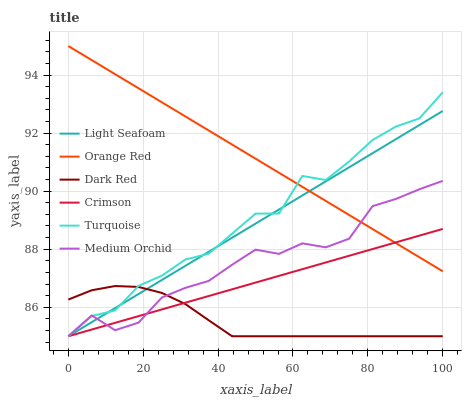Does Dark Red have the minimum area under the curve?
Answer yes or no. Yes. Does Orange Red have the maximum area under the curve?
Answer yes or no. Yes. Does Medium Orchid have the minimum area under the curve?
Answer yes or no. No. Does Medium Orchid have the maximum area under the curve?
Answer yes or no. No. Is Light Seafoam the smoothest?
Answer yes or no. Yes. Is Turquoise the roughest?
Answer yes or no. Yes. Is Dark Red the smoothest?
Answer yes or no. No. Is Dark Red the roughest?
Answer yes or no. No. Does Turquoise have the lowest value?
Answer yes or no. Yes. Does Orange Red have the lowest value?
Answer yes or no. No. Does Orange Red have the highest value?
Answer yes or no. Yes. Does Medium Orchid have the highest value?
Answer yes or no. No. Is Dark Red less than Orange Red?
Answer yes or no. Yes. Is Orange Red greater than Dark Red?
Answer yes or no. Yes. Does Medium Orchid intersect Crimson?
Answer yes or no. Yes. Is Medium Orchid less than Crimson?
Answer yes or no. No. Is Medium Orchid greater than Crimson?
Answer yes or no. No. Does Dark Red intersect Orange Red?
Answer yes or no. No. 